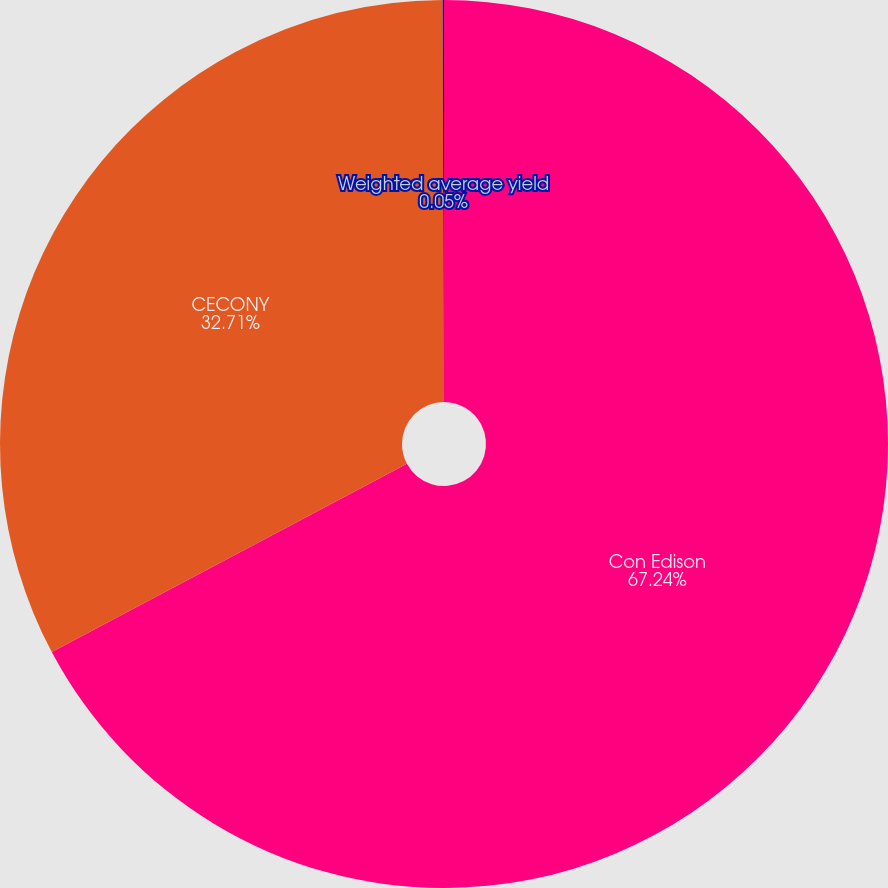Convert chart to OTSL. <chart><loc_0><loc_0><loc_500><loc_500><pie_chart><fcel>Con Edison<fcel>CECONY<fcel>Weighted average yield<nl><fcel>67.23%<fcel>32.71%<fcel>0.05%<nl></chart> 